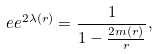<formula> <loc_0><loc_0><loc_500><loc_500>\ e e ^ { 2 \lambda ( r ) } = \frac { 1 } { 1 - \frac { 2 m ( r ) } { r } } ,</formula> 